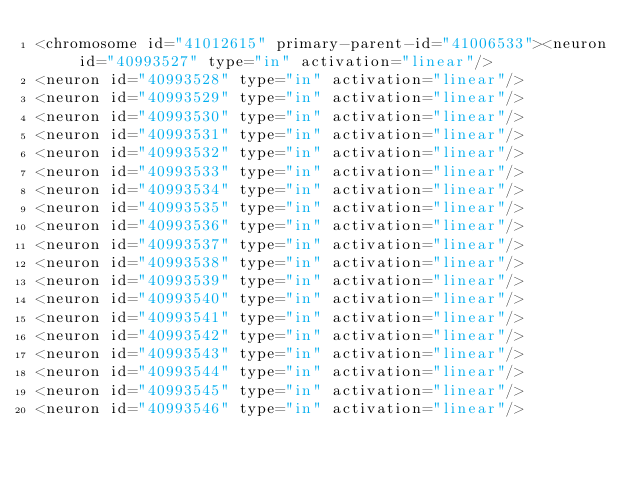Convert code to text. <code><loc_0><loc_0><loc_500><loc_500><_XML_><chromosome id="41012615" primary-parent-id="41006533"><neuron id="40993527" type="in" activation="linear"/>
<neuron id="40993528" type="in" activation="linear"/>
<neuron id="40993529" type="in" activation="linear"/>
<neuron id="40993530" type="in" activation="linear"/>
<neuron id="40993531" type="in" activation="linear"/>
<neuron id="40993532" type="in" activation="linear"/>
<neuron id="40993533" type="in" activation="linear"/>
<neuron id="40993534" type="in" activation="linear"/>
<neuron id="40993535" type="in" activation="linear"/>
<neuron id="40993536" type="in" activation="linear"/>
<neuron id="40993537" type="in" activation="linear"/>
<neuron id="40993538" type="in" activation="linear"/>
<neuron id="40993539" type="in" activation="linear"/>
<neuron id="40993540" type="in" activation="linear"/>
<neuron id="40993541" type="in" activation="linear"/>
<neuron id="40993542" type="in" activation="linear"/>
<neuron id="40993543" type="in" activation="linear"/>
<neuron id="40993544" type="in" activation="linear"/>
<neuron id="40993545" type="in" activation="linear"/>
<neuron id="40993546" type="in" activation="linear"/></code> 